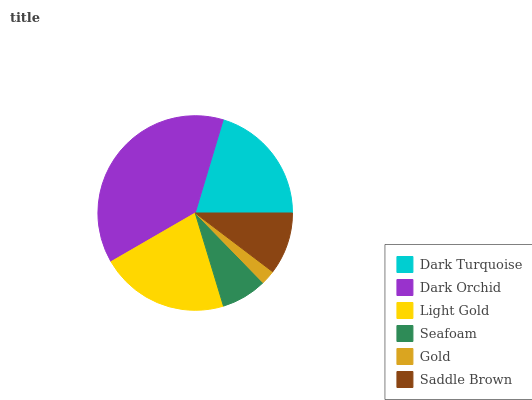Is Gold the minimum?
Answer yes or no. Yes. Is Dark Orchid the maximum?
Answer yes or no. Yes. Is Light Gold the minimum?
Answer yes or no. No. Is Light Gold the maximum?
Answer yes or no. No. Is Dark Orchid greater than Light Gold?
Answer yes or no. Yes. Is Light Gold less than Dark Orchid?
Answer yes or no. Yes. Is Light Gold greater than Dark Orchid?
Answer yes or no. No. Is Dark Orchid less than Light Gold?
Answer yes or no. No. Is Dark Turquoise the high median?
Answer yes or no. Yes. Is Saddle Brown the low median?
Answer yes or no. Yes. Is Light Gold the high median?
Answer yes or no. No. Is Dark Orchid the low median?
Answer yes or no. No. 